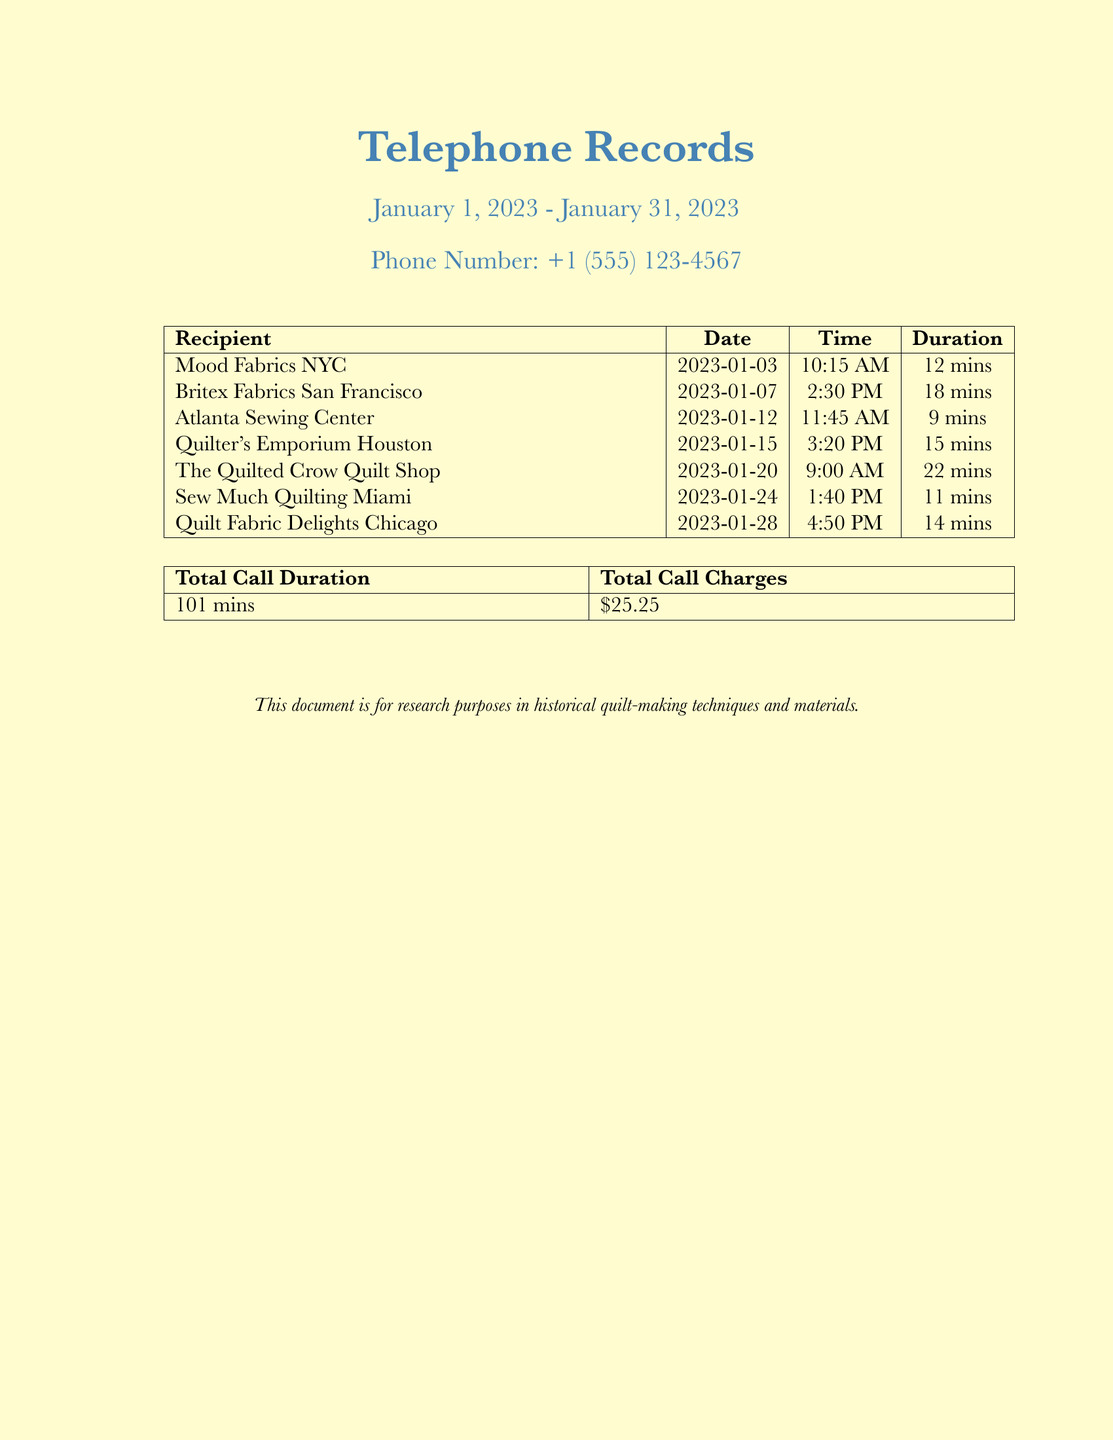What is the phone number? The phone number mentioned in the document is listed.
Answer: +1 (555) 123-4567 How many calls were made to fabric stores? The document shows a list of calls to fabric-related businesses.
Answer: 7 What is the total call duration? The total call duration is provided in a summary table at the end of the document.
Answer: 101 mins Which store was called on January 12, 2023? The date allows us to identify the specific store that was called.
Answer: Atlanta Sewing Center What was the duration of the longest call? By comparing all durations, we can find the longest one.
Answer: 22 mins What was the total call charge? The total call charge is summarized in the document.
Answer: $25.25 Which store was called at 1:40 PM on January 24, 2023? The time helps identify which specific store was contacted.
Answer: Sew Much Quilting Miami How many minutes was the call to Britex Fabrics? The document specifies the duration of that particular call.
Answer: 18 mins 